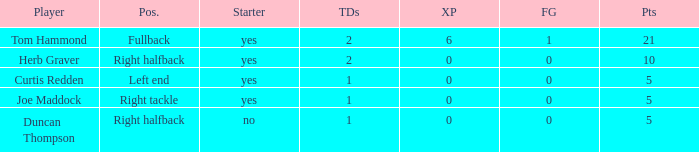Name the fewest touchdowns 1.0. 